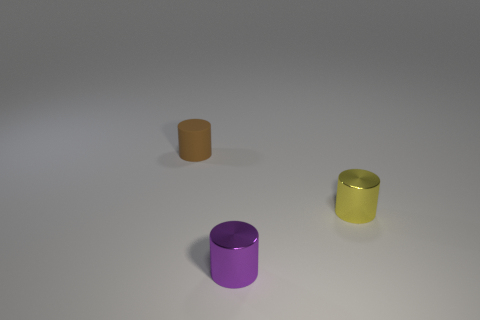Is the number of purple metal things on the right side of the small brown rubber object greater than the number of tiny yellow cylinders left of the purple thing?
Offer a very short reply. Yes. Is the number of tiny brown cylinders greater than the number of green metal blocks?
Offer a very short reply. Yes. What shape is the tiny purple metal thing?
Offer a very short reply. Cylinder. Are there more tiny matte cylinders that are on the left side of the tiny yellow metal cylinder than large yellow cylinders?
Your response must be concise. Yes. What shape is the tiny metal thing right of the small object in front of the cylinder that is to the right of the tiny purple metal thing?
Your response must be concise. Cylinder. What shape is the tiny object that is both on the left side of the tiny yellow cylinder and to the right of the brown rubber object?
Your answer should be compact. Cylinder. The object on the left side of the small metal thing in front of the small object right of the purple object is what color?
Keep it short and to the point. Brown. What color is the rubber object that is the same shape as the tiny yellow metal object?
Your response must be concise. Brown. Is the number of rubber objects in front of the small yellow object the same as the number of small blue shiny objects?
Your answer should be compact. Yes. How many cylinders are either small objects or small purple metal things?
Your response must be concise. 3. 